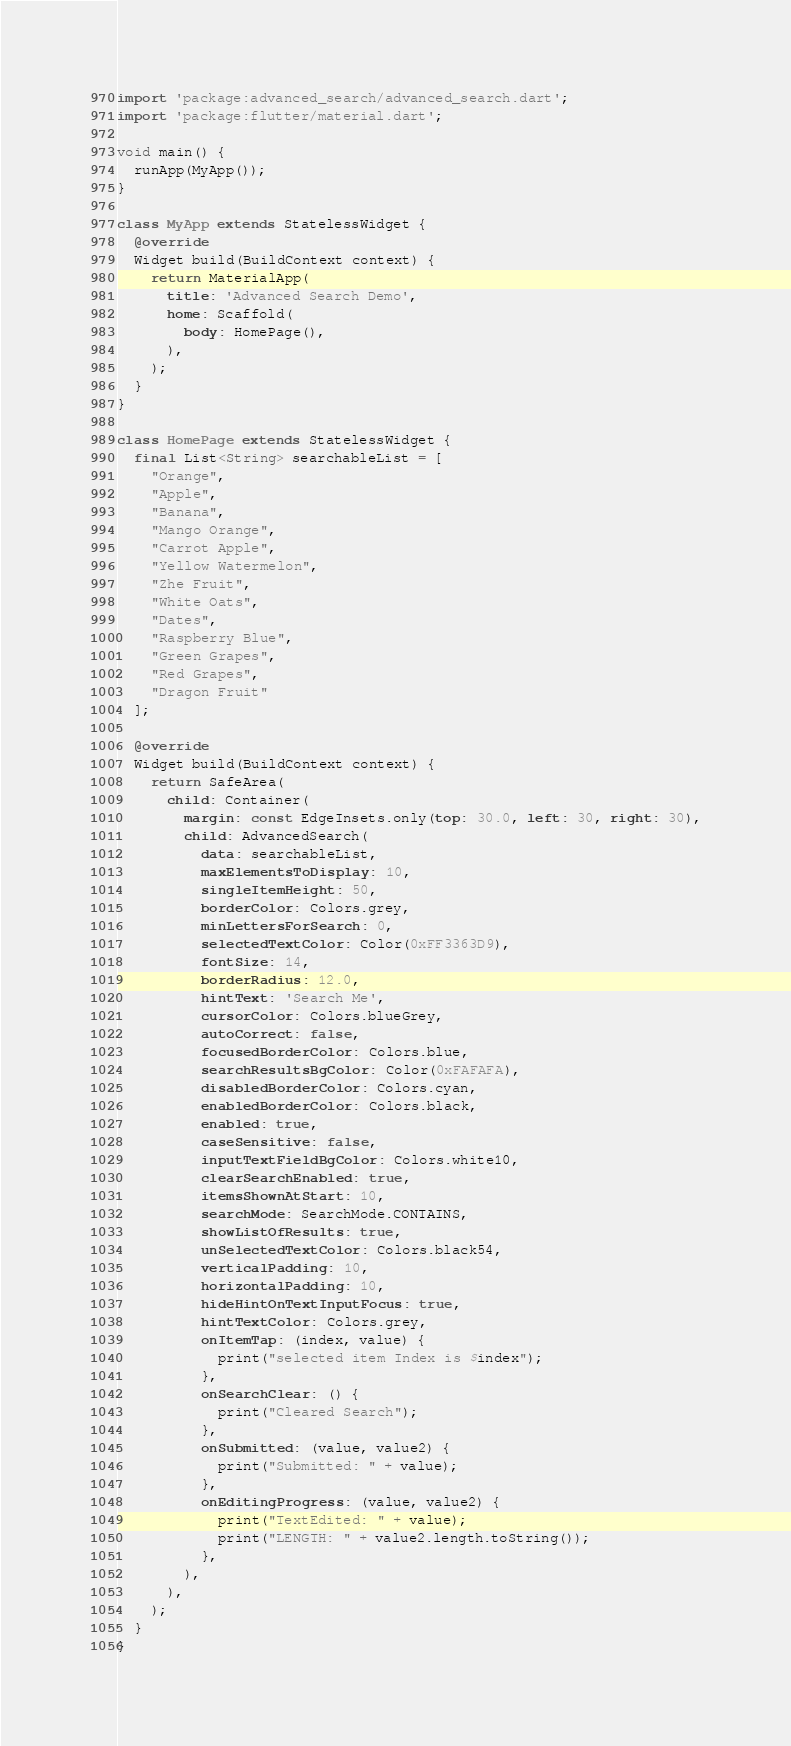<code> <loc_0><loc_0><loc_500><loc_500><_Dart_>import 'package:advanced_search/advanced_search.dart';
import 'package:flutter/material.dart';

void main() {
  runApp(MyApp());
}

class MyApp extends StatelessWidget {
  @override
  Widget build(BuildContext context) {
    return MaterialApp(
      title: 'Advanced Search Demo',
      home: Scaffold(
        body: HomePage(),
      ),
    );
  }
}

class HomePage extends StatelessWidget {
  final List<String> searchableList = [
    "Orange",
    "Apple",
    "Banana",
    "Mango Orange",
    "Carrot Apple",
    "Yellow Watermelon",
    "Zhe Fruit",
    "White Oats",
    "Dates",
    "Raspberry Blue",
    "Green Grapes",
    "Red Grapes",
    "Dragon Fruit"
  ];

  @override
  Widget build(BuildContext context) {
    return SafeArea(
      child: Container(
        margin: const EdgeInsets.only(top: 30.0, left: 30, right: 30),
        child: AdvancedSearch(
          data: searchableList,
          maxElementsToDisplay: 10,
          singleItemHeight: 50,
          borderColor: Colors.grey,
          minLettersForSearch: 0,
          selectedTextColor: Color(0xFF3363D9),
          fontSize: 14,
          borderRadius: 12.0,
          hintText: 'Search Me',
          cursorColor: Colors.blueGrey,
          autoCorrect: false,
          focusedBorderColor: Colors.blue,
          searchResultsBgColor: Color(0xFAFAFA),
          disabledBorderColor: Colors.cyan,
          enabledBorderColor: Colors.black,
          enabled: true,
          caseSensitive: false,
          inputTextFieldBgColor: Colors.white10,
          clearSearchEnabled: true,
          itemsShownAtStart: 10,
          searchMode: SearchMode.CONTAINS,
          showListOfResults: true,
          unSelectedTextColor: Colors.black54,
          verticalPadding: 10,
          horizontalPadding: 10,
          hideHintOnTextInputFocus: true,
          hintTextColor: Colors.grey,
          onItemTap: (index, value) {
            print("selected item Index is $index");
          },
          onSearchClear: () {
            print("Cleared Search");
          },
          onSubmitted: (value, value2) {
            print("Submitted: " + value);
          },
          onEditingProgress: (value, value2) {
            print("TextEdited: " + value);
            print("LENGTH: " + value2.length.toString());
          },
        ),
      ),
    );
  }
}
</code> 